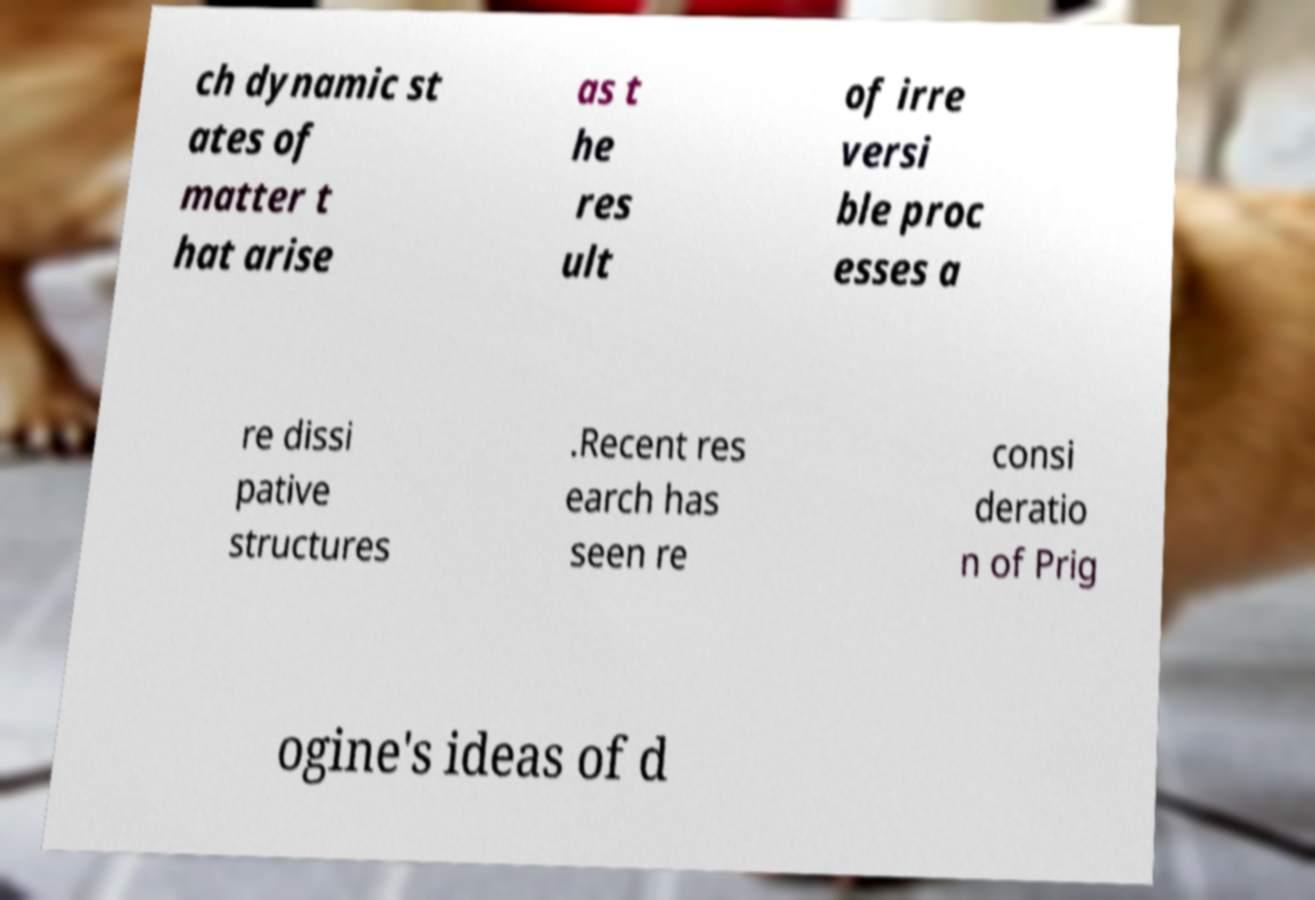I need the written content from this picture converted into text. Can you do that? ch dynamic st ates of matter t hat arise as t he res ult of irre versi ble proc esses a re dissi pative structures .Recent res earch has seen re consi deratio n of Prig ogine's ideas of d 